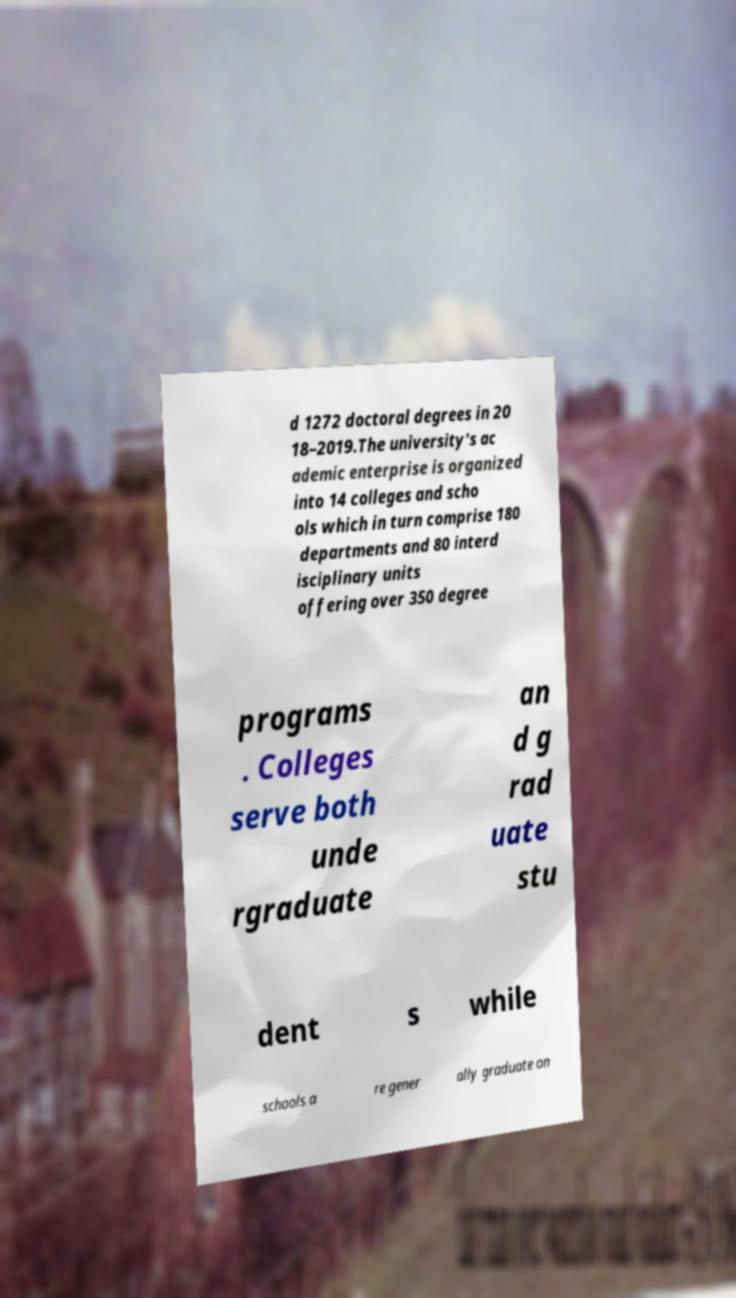There's text embedded in this image that I need extracted. Can you transcribe it verbatim? d 1272 doctoral degrees in 20 18–2019.The university's ac ademic enterprise is organized into 14 colleges and scho ols which in turn comprise 180 departments and 80 interd isciplinary units offering over 350 degree programs . Colleges serve both unde rgraduate an d g rad uate stu dent s while schools a re gener ally graduate on 